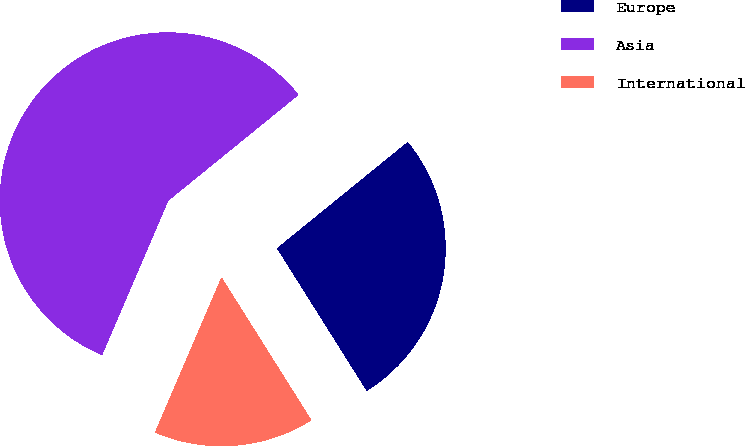Convert chart to OTSL. <chart><loc_0><loc_0><loc_500><loc_500><pie_chart><fcel>Europe<fcel>Asia<fcel>International<nl><fcel>26.92%<fcel>57.69%<fcel>15.38%<nl></chart> 